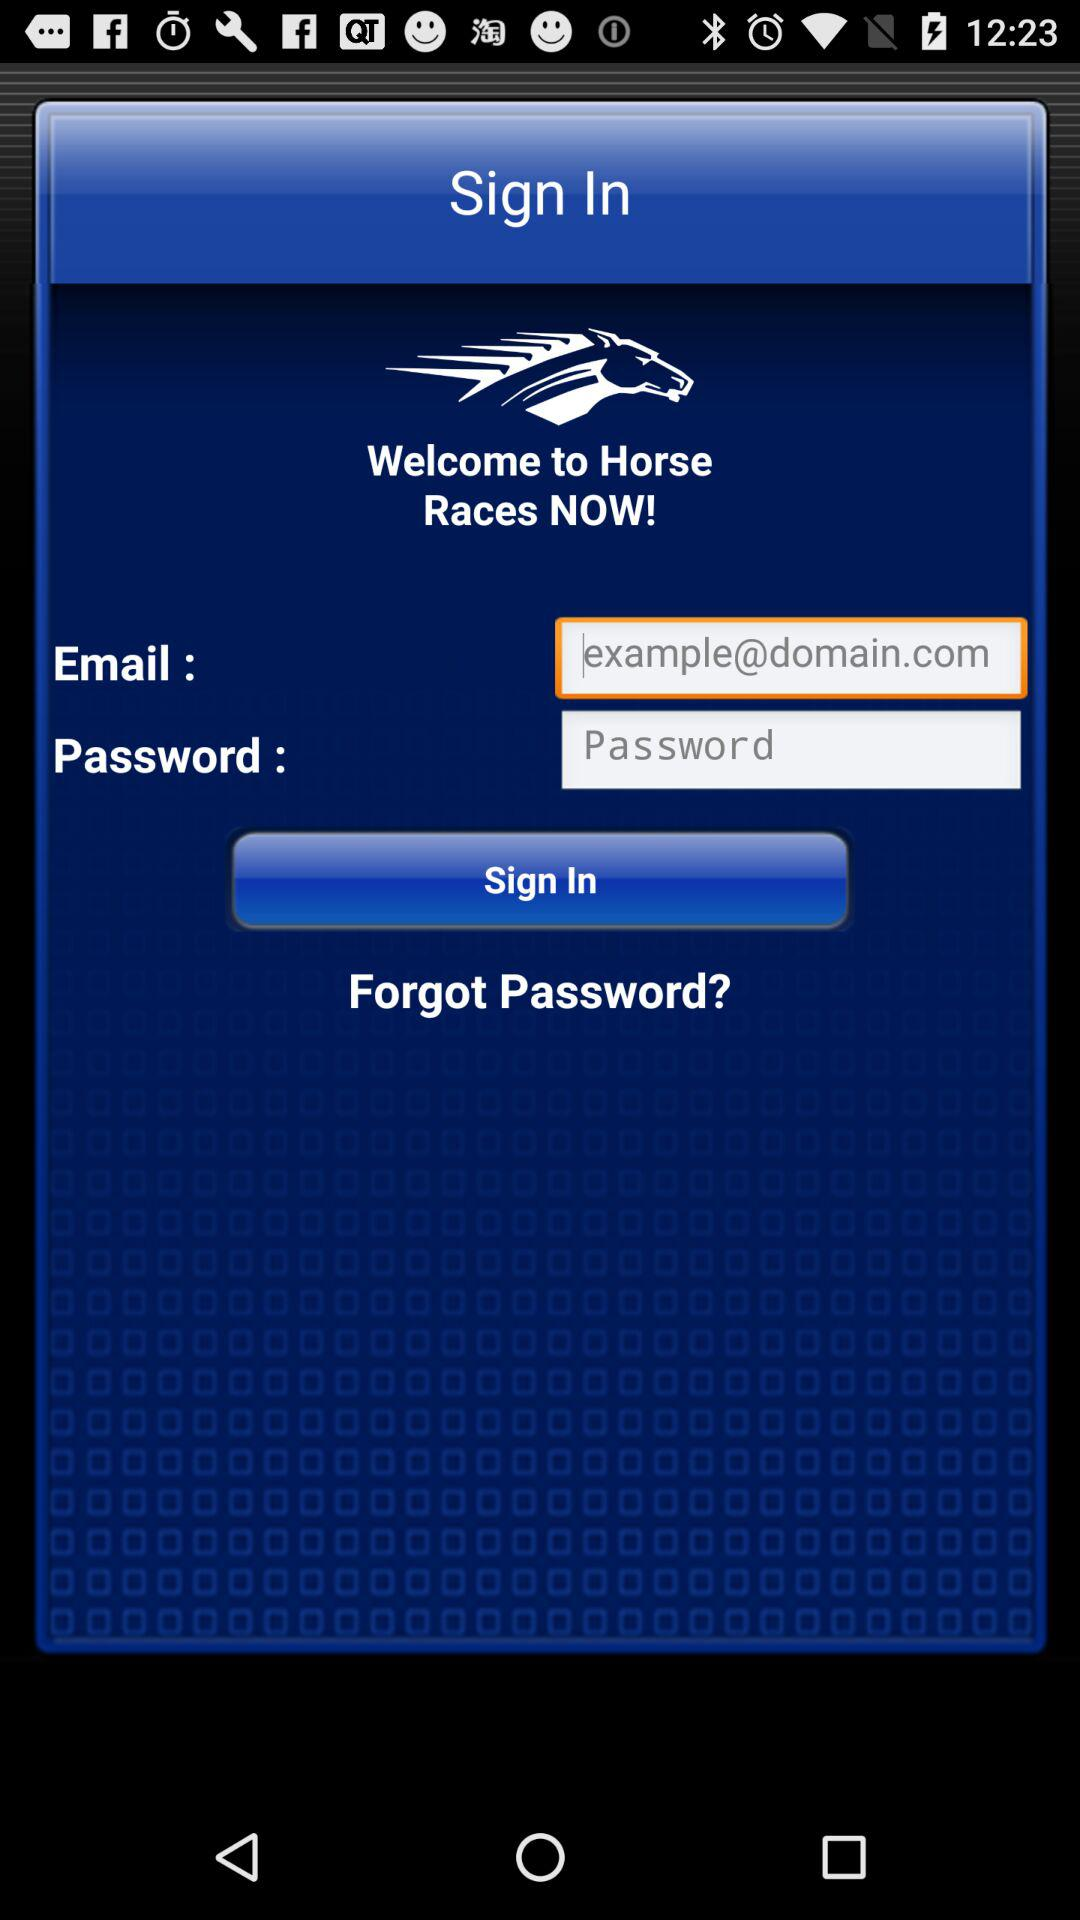What is the application name? The application name is "Horse Races NOW". 